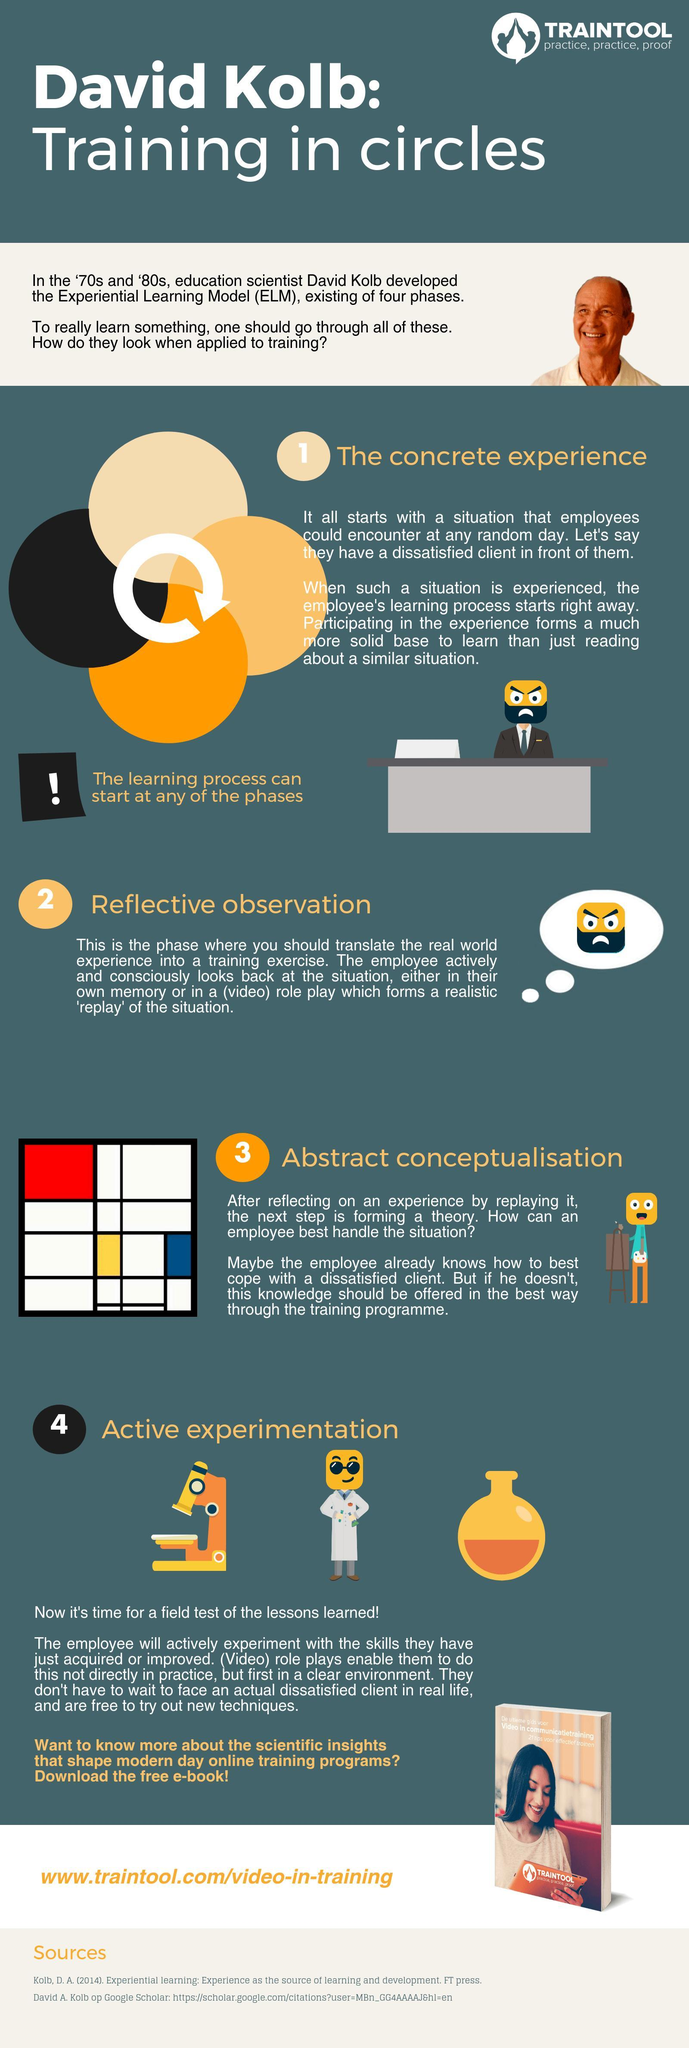How many sources are listed?
Answer the question with a short phrase. 2 